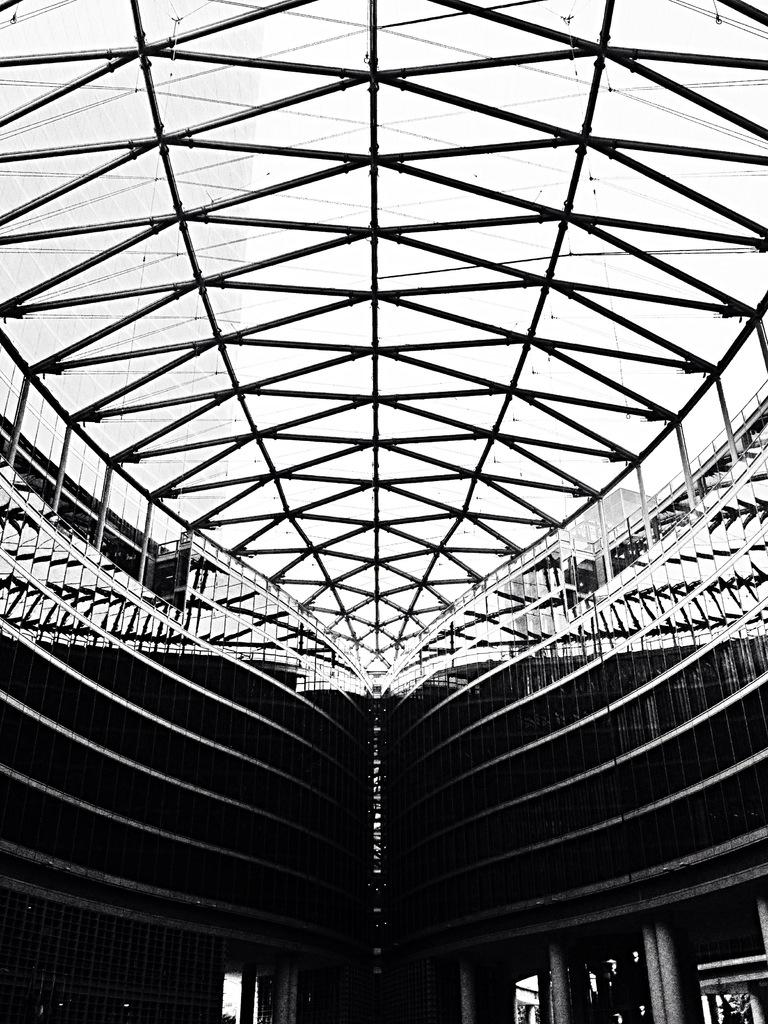What type of space is shown in the image? The image is an inside view of a room. What can be seen above the room in the image? There is a roof visible in the image. What provides illumination in the room? There are lights in the room. What surrounds the room to create its boundaries? There are walls in the room. What structural elements support the roof in the room? There are pillars in the room. What allows natural light to enter the room? There are windows in the room. How many brothers are standing near the pillars in the image? There is no mention of brothers in the image, and therefore no such individuals can be observed. 